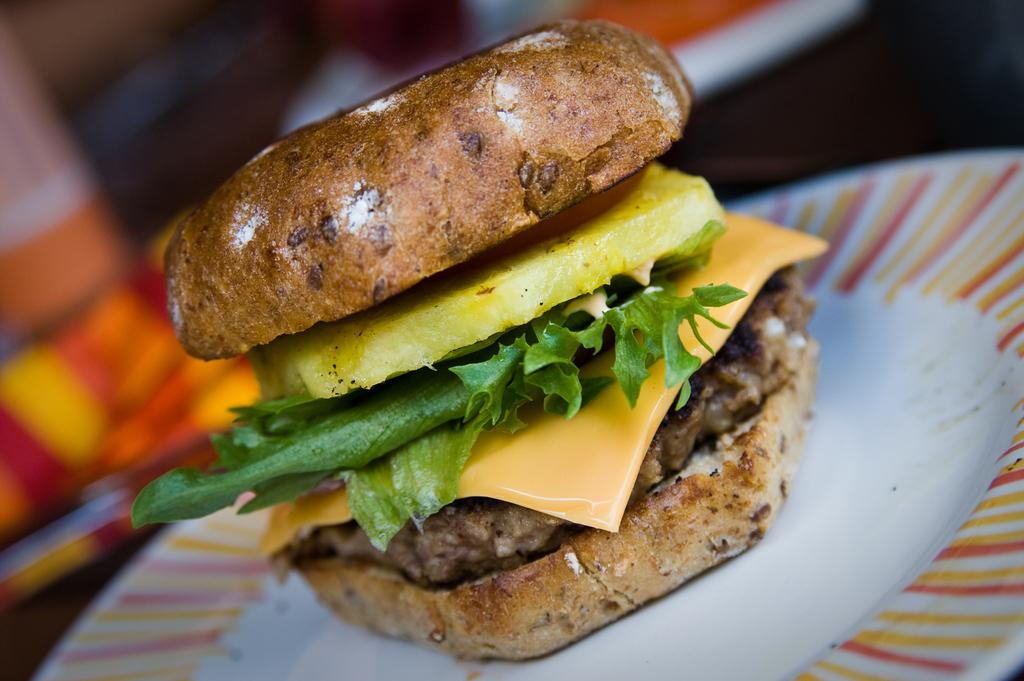What is on the plate that is visible in the image? There is a plate with food in the image. Can you describe the background of the image? The background of the image is blurry. How many legs can be seen in the image? There are no legs visible in the image. Is there a door present in the image? There is no door present in the image. What type of shoes can be seen in the image? There are no shoes present in the image. 